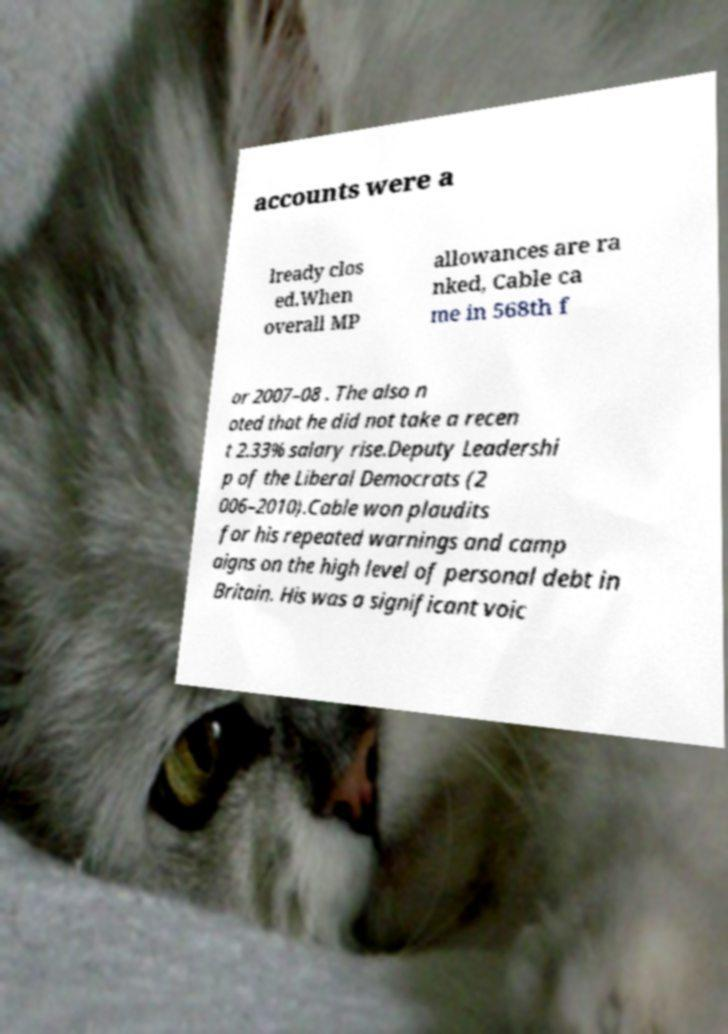Could you extract and type out the text from this image? accounts were a lready clos ed.When overall MP allowances are ra nked, Cable ca me in 568th f or 2007–08 . The also n oted that he did not take a recen t 2.33% salary rise.Deputy Leadershi p of the Liberal Democrats (2 006–2010).Cable won plaudits for his repeated warnings and camp aigns on the high level of personal debt in Britain. His was a significant voic 